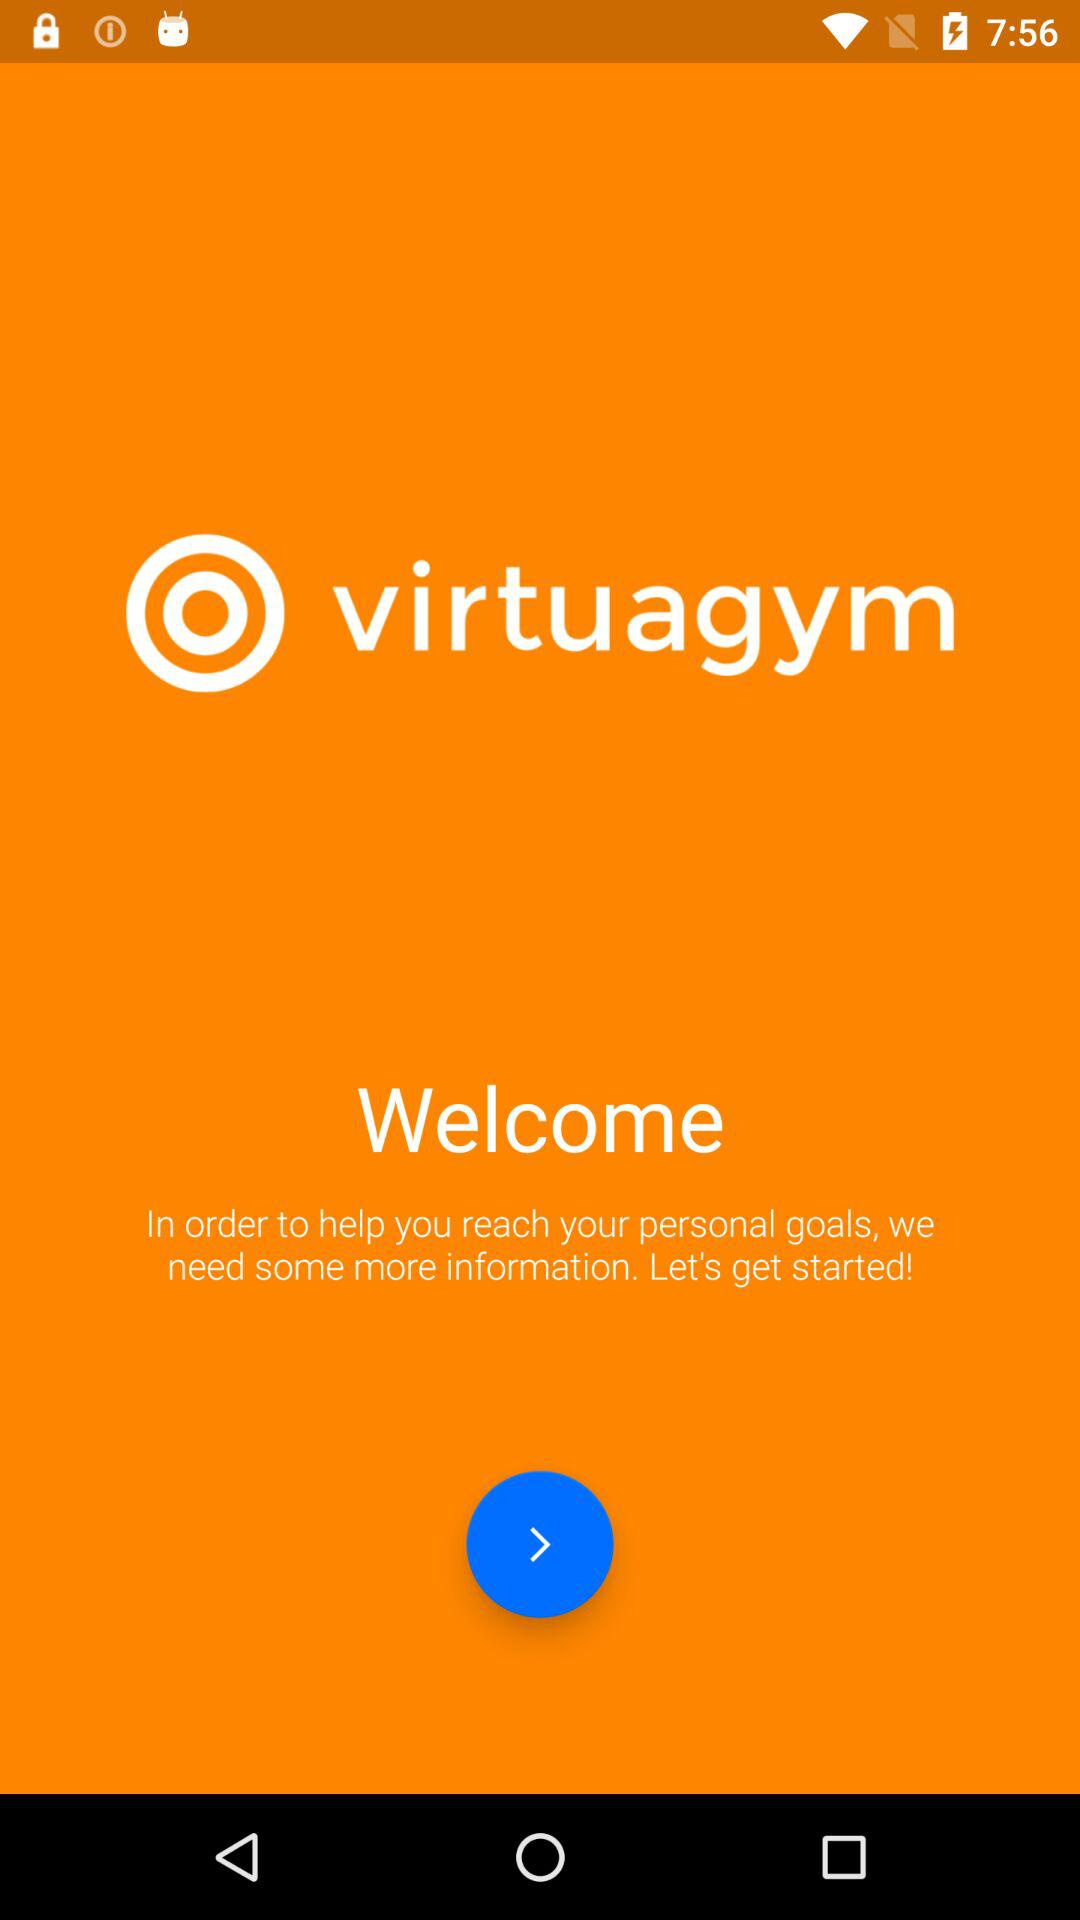What is the name of the application? The name of the application is "virtuagym". 